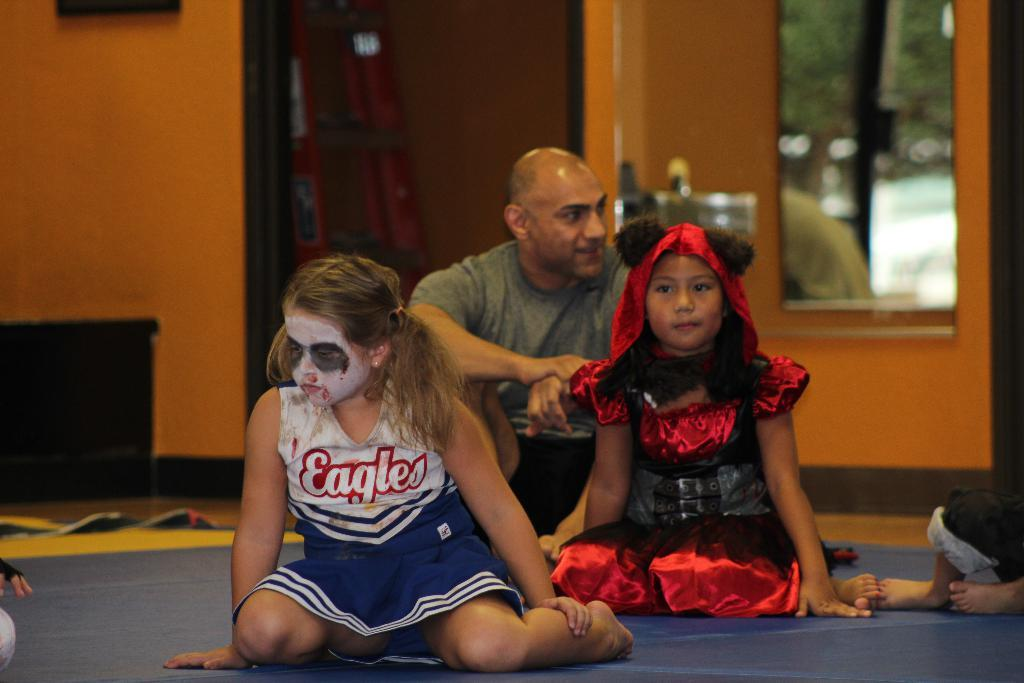<image>
Summarize the visual content of the image. Two girls in costumes and a man are sitting on the floor, one of the girls in an Eagles cheerleading uniform with scary make up on her face. 